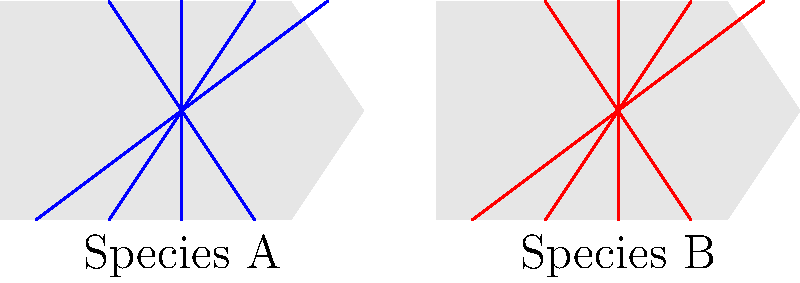Compare the wing venation patterns of Species A and Species B in the diagram. Which of the following statements is true regarding their relationship?

a) The venation patterns are mirror images of each other
b) Species B has more longitudinal veins than Species A
c) The venation patterns are identical
d) Species A has more cross-veins than Species B To answer this question, we need to carefully analyze the wing venation patterns of both species:

1. First, observe the general structure of the veins in both wings:
   - Species A (left wing) has blue veins
   - Species B (right wing) has red veins

2. Count the number of longitudinal veins:
   - Both Species A and B have 4 longitudinal veins

3. Examine the orientation of the veins:
   - In Species A, the veins are angled from bottom-left to top-right
   - In Species B, the veins are angled from bottom-right to top-left

4. Check for cross-veins:
   - Neither species shows any visible cross-veins in this diagram

5. Compare the overall patterns:
   - The venation patterns are not identical
   - The patterns appear to be mirror images of each other, with the veins angled in opposite directions

Based on this analysis, we can conclude that the venation patterns of Species A and Species B are mirror images of each other. This corresponds to option a) in the question.
Answer: a) The venation patterns are mirror images of each other 